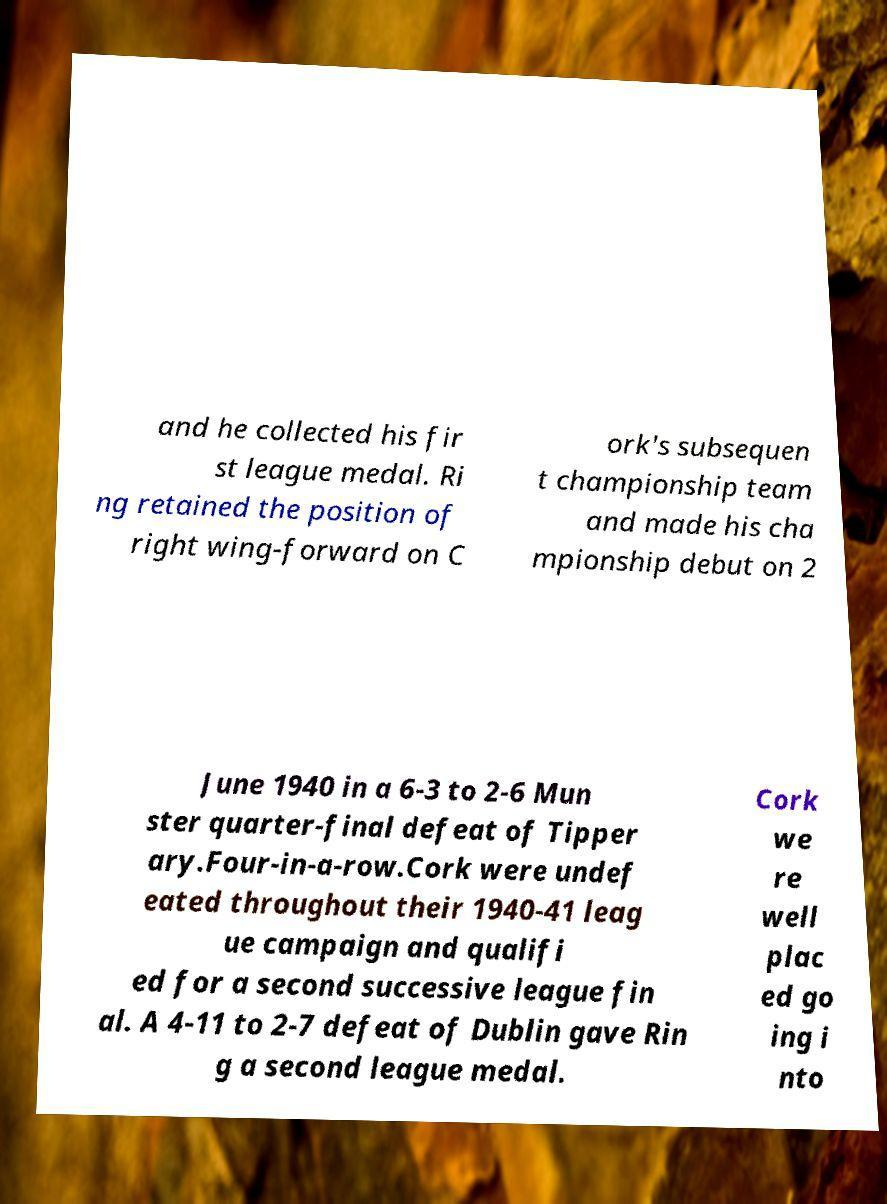Please read and relay the text visible in this image. What does it say? and he collected his fir st league medal. Ri ng retained the position of right wing-forward on C ork's subsequen t championship team and made his cha mpionship debut on 2 June 1940 in a 6-3 to 2-6 Mun ster quarter-final defeat of Tipper ary.Four-in-a-row.Cork were undef eated throughout their 1940-41 leag ue campaign and qualifi ed for a second successive league fin al. A 4-11 to 2-7 defeat of Dublin gave Rin g a second league medal. Cork we re well plac ed go ing i nto 